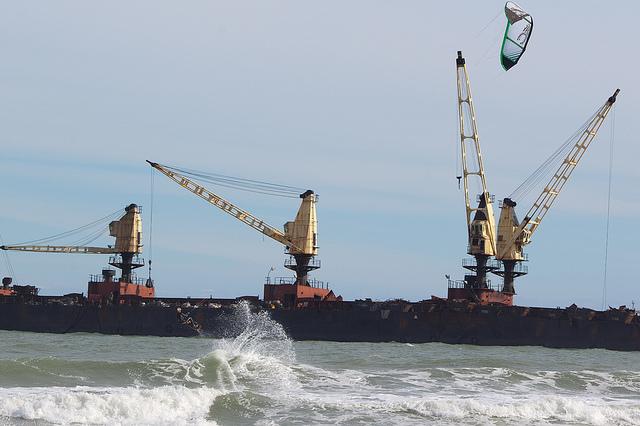Are those cranes?
Quick response, please. Yes. What is in the sky?
Write a very short answer. Kite. Is this on a shore?
Short answer required. No. 